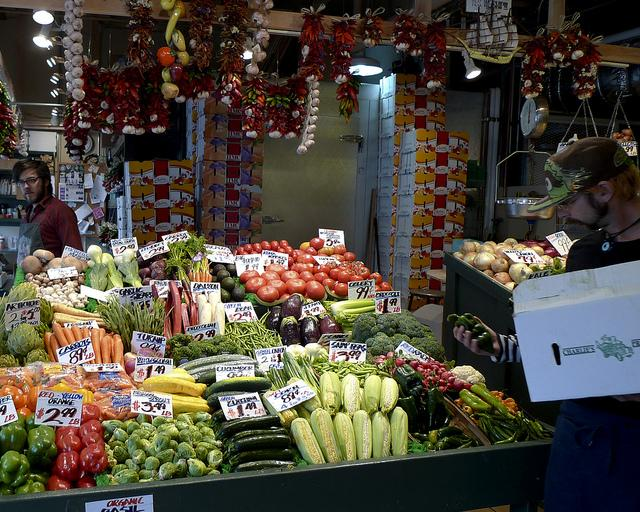Which vegetable is likely the most expensive item by piece or pound?

Choices:
A) artichoke
B) celery
C) corn
D) turnips artichoke 